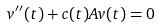<formula> <loc_0><loc_0><loc_500><loc_500>v ^ { \prime \prime } ( t ) + c ( t ) A v ( t ) = 0</formula> 